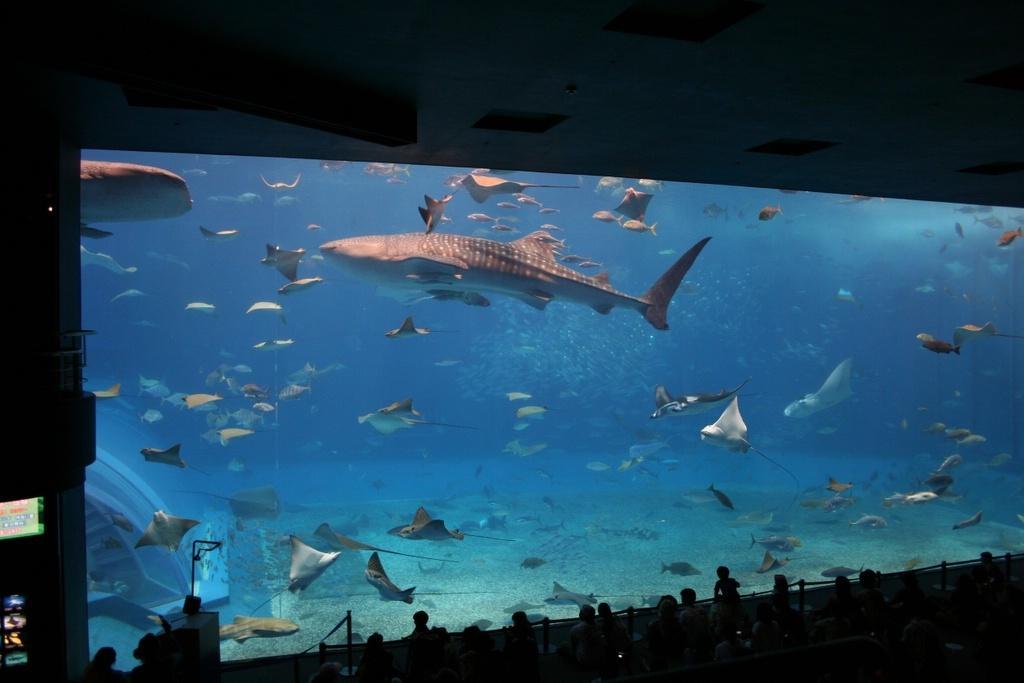In one or two sentences, can you explain what this image depicts? In this image I can see a huge aquarium and in the aquarium I can see the water and number of aquatic animals. To the bottom of the image I can see few persons and to the top of the image I can see the ceiling. 